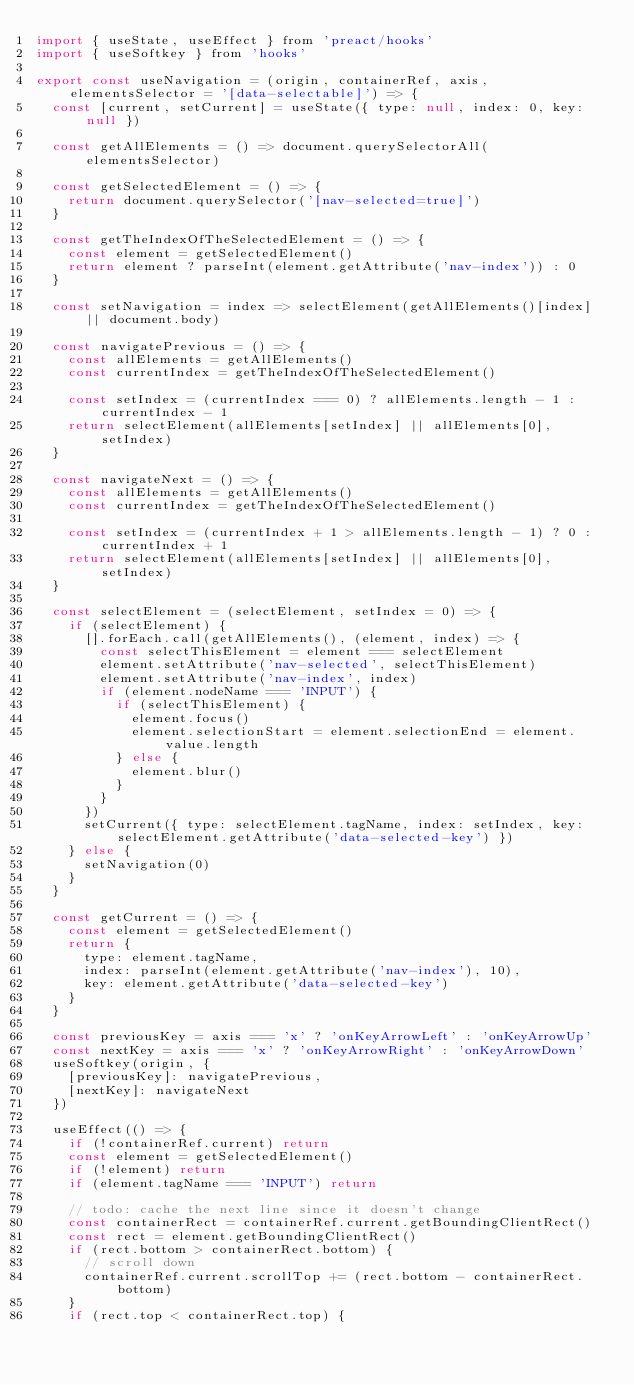<code> <loc_0><loc_0><loc_500><loc_500><_JavaScript_>import { useState, useEffect } from 'preact/hooks'
import { useSoftkey } from 'hooks'

export const useNavigation = (origin, containerRef, axis, elementsSelector = '[data-selectable]') => {
  const [current, setCurrent] = useState({ type: null, index: 0, key: null })

  const getAllElements = () => document.querySelectorAll(elementsSelector)

  const getSelectedElement = () => {
    return document.querySelector('[nav-selected=true]')
  }

  const getTheIndexOfTheSelectedElement = () => {
    const element = getSelectedElement()
    return element ? parseInt(element.getAttribute('nav-index')) : 0
  }

  const setNavigation = index => selectElement(getAllElements()[index] || document.body)

  const navigatePrevious = () => {
    const allElements = getAllElements()
    const currentIndex = getTheIndexOfTheSelectedElement()

    const setIndex = (currentIndex === 0) ? allElements.length - 1 : currentIndex - 1
    return selectElement(allElements[setIndex] || allElements[0], setIndex)
  }

  const navigateNext = () => {
    const allElements = getAllElements()
    const currentIndex = getTheIndexOfTheSelectedElement()

    const setIndex = (currentIndex + 1 > allElements.length - 1) ? 0 : currentIndex + 1
    return selectElement(allElements[setIndex] || allElements[0], setIndex)
  }

  const selectElement = (selectElement, setIndex = 0) => {
    if (selectElement) {
      [].forEach.call(getAllElements(), (element, index) => {
        const selectThisElement = element === selectElement
        element.setAttribute('nav-selected', selectThisElement)
        element.setAttribute('nav-index', index)
        if (element.nodeName === 'INPUT') {
          if (selectThisElement) {
            element.focus()
            element.selectionStart = element.selectionEnd = element.value.length
          } else {
            element.blur()
          }
        }
      })
      setCurrent({ type: selectElement.tagName, index: setIndex, key: selectElement.getAttribute('data-selected-key') })
    } else {
      setNavigation(0)
    }
  }

  const getCurrent = () => {
    const element = getSelectedElement()
    return {
      type: element.tagName,
      index: parseInt(element.getAttribute('nav-index'), 10),
      key: element.getAttribute('data-selected-key')
    }
  }

  const previousKey = axis === 'x' ? 'onKeyArrowLeft' : 'onKeyArrowUp'
  const nextKey = axis === 'x' ? 'onKeyArrowRight' : 'onKeyArrowDown'
  useSoftkey(origin, {
    [previousKey]: navigatePrevious,
    [nextKey]: navigateNext
  })

  useEffect(() => {
    if (!containerRef.current) return
    const element = getSelectedElement()
    if (!element) return
    if (element.tagName === 'INPUT') return

    // todo: cache the next line since it doesn't change
    const containerRect = containerRef.current.getBoundingClientRect()
    const rect = element.getBoundingClientRect()
    if (rect.bottom > containerRect.bottom) {
      // scroll down
      containerRef.current.scrollTop += (rect.bottom - containerRect.bottom)
    }
    if (rect.top < containerRect.top) {</code> 